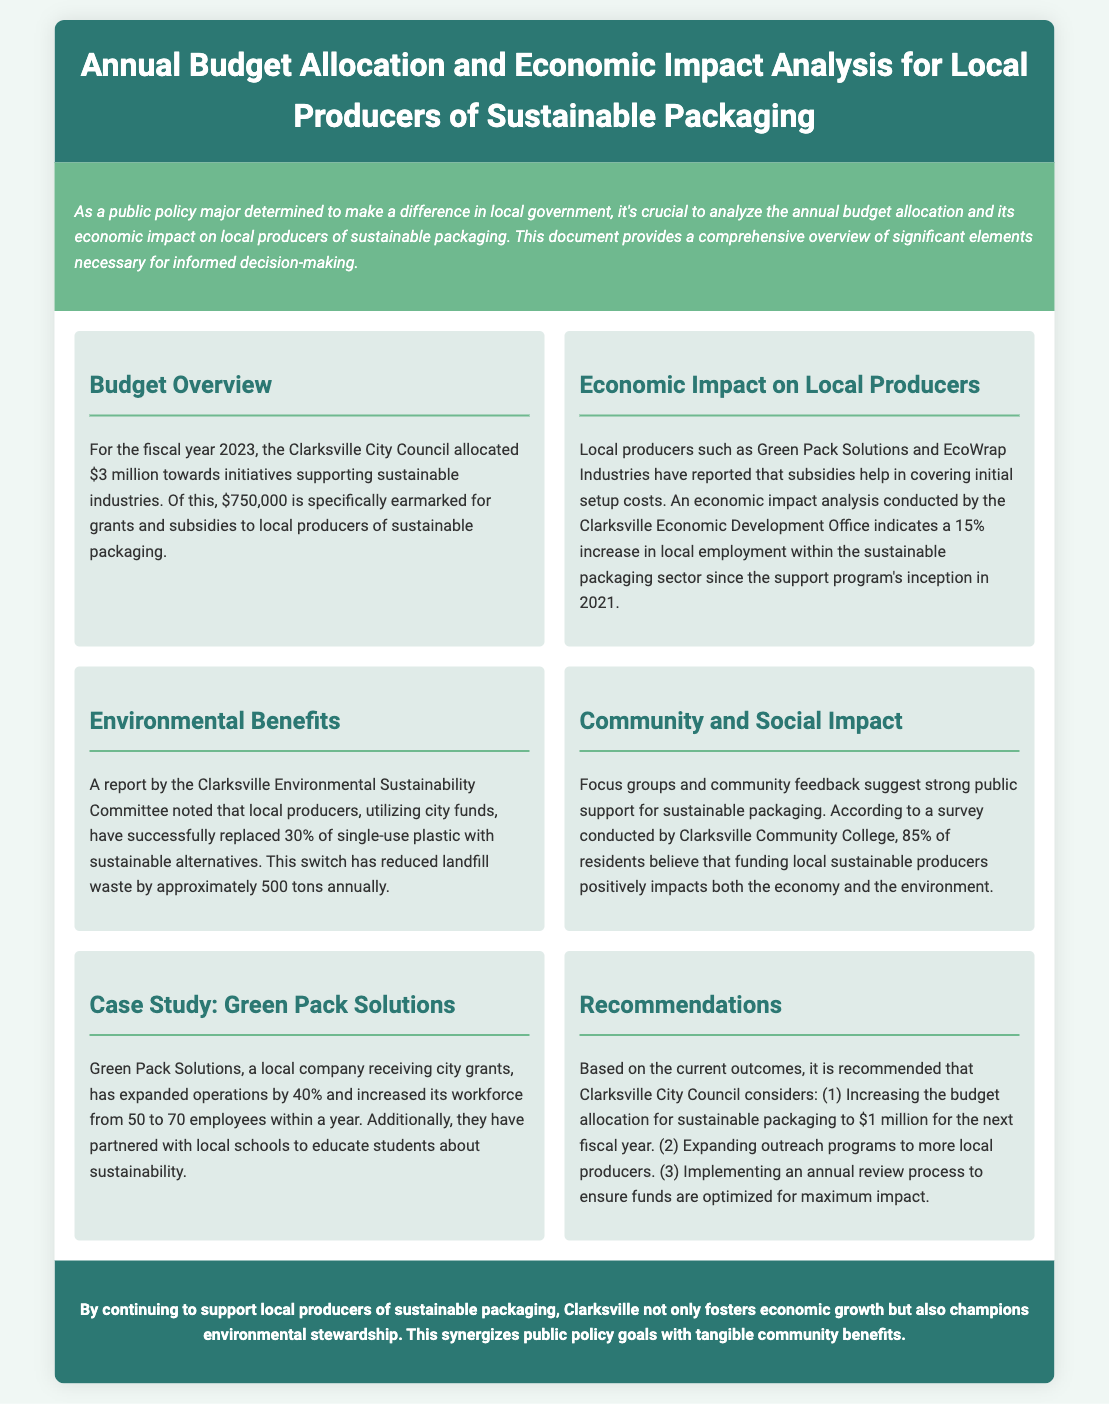What is the budget allocation for local producers of sustainable packaging? The budget allocation for local producers of sustainable packaging, as stated in the document, is $750,000.
Answer: $750,000 What year did the support program for sustainable packaging begin? The support program for sustainable packaging began in 2021, according to the economic impact analysis.
Answer: 2021 How much has Green Pack Solutions increased its workforce? Green Pack Solutions increased its workforce from 50 to 70 employees, which is a growth of 20 employees.
Answer: 20 employees What percentage of single-use plastic has been replaced by sustainable alternatives? The document states that local producers have replaced 30% of single-use plastic with sustainable alternatives.
Answer: 30% What is the recommended budget allocation for sustainable packaging for the next fiscal year? It is recommended that the budget allocation for sustainable packaging be increased to $1 million for the next fiscal year.
Answer: $1 million According to a survey, what percentage of residents supports funding local sustainable producers? The survey indicated that 85% of residents believe that funding local sustainable producers is beneficial.
Answer: 85% What was the total budget allocated by the Clarksville City Council for initiatives supporting sustainable industries? The total budget allocated for sustainable industries by the Clarksville City Council is $3 million.
Answer: $3 million Which local companies are mentioned in the economic impact analysis? The local companies mentioned in the economic impact analysis are Green Pack Solutions and EcoWrap Industries.
Answer: Green Pack Solutions and EcoWrap Industries What impact has the support program had on local employment in the sustainable packaging sector? The document mentions a 15% increase in local employment within the sustainable packaging sector since the support program's inception.
Answer: 15% 